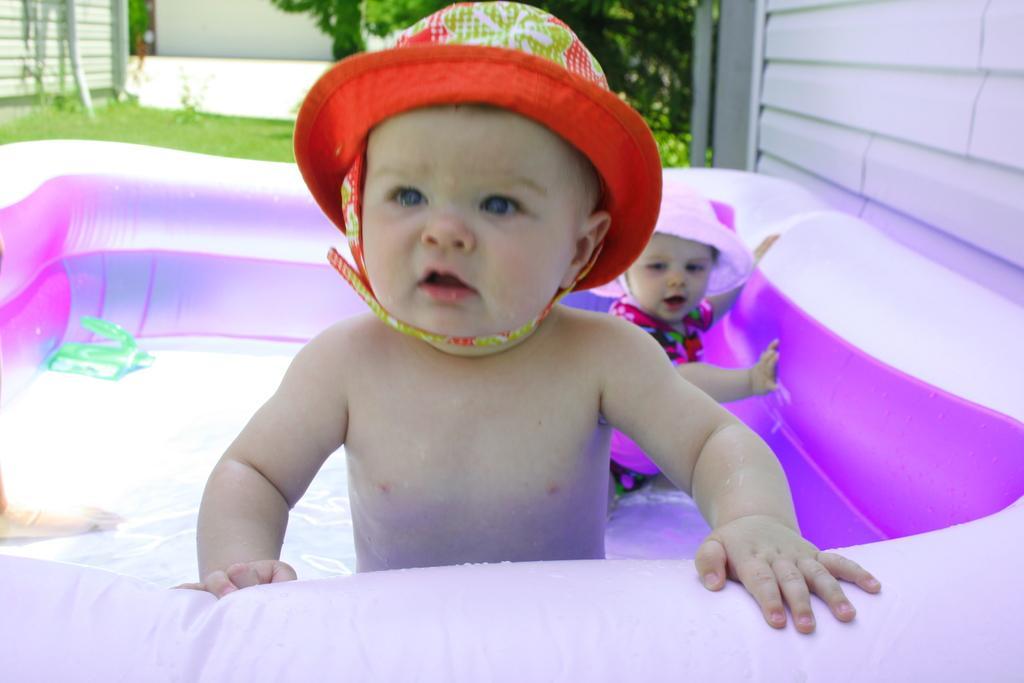Describe this image in one or two sentences. In the image we can see a water balloon. In the water balloon few kids are standing. Behind them there is grass and trees and wall. 